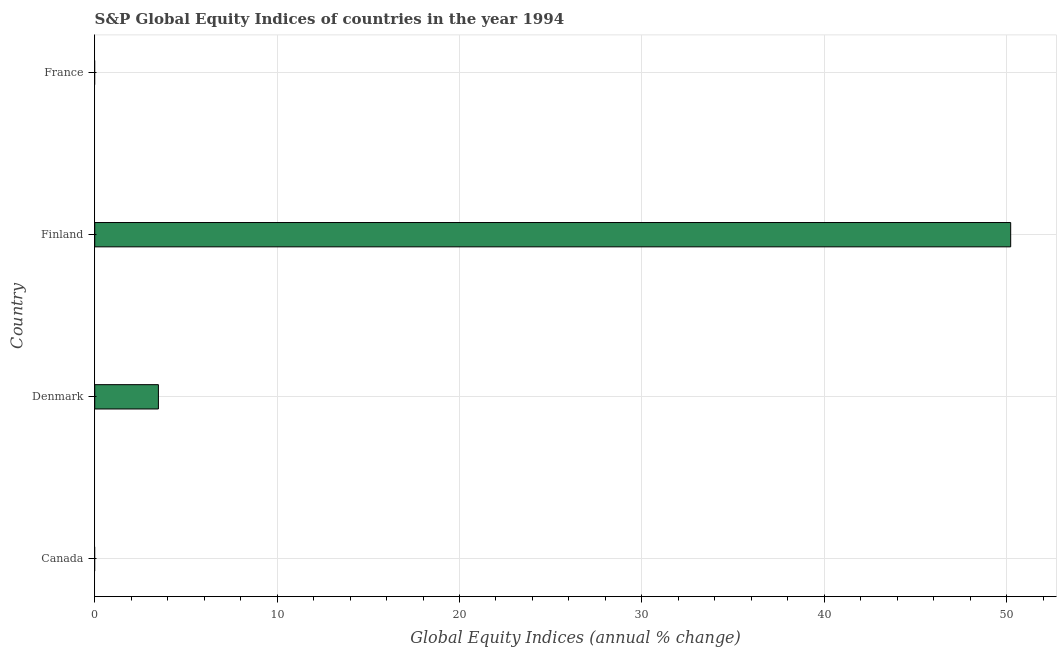Does the graph contain grids?
Offer a terse response. Yes. What is the title of the graph?
Provide a short and direct response. S&P Global Equity Indices of countries in the year 1994. What is the label or title of the X-axis?
Your response must be concise. Global Equity Indices (annual % change). What is the s&p global equity indices in Finland?
Make the answer very short. 50.23. Across all countries, what is the maximum s&p global equity indices?
Offer a very short reply. 50.23. Across all countries, what is the minimum s&p global equity indices?
Your response must be concise. 0. What is the sum of the s&p global equity indices?
Offer a very short reply. 53.72. What is the difference between the s&p global equity indices in Denmark and Finland?
Your answer should be very brief. -46.73. What is the average s&p global equity indices per country?
Your response must be concise. 13.43. What is the median s&p global equity indices?
Your response must be concise. 1.75. What is the ratio of the s&p global equity indices in Denmark to that in Finland?
Provide a short and direct response. 0.07. What is the difference between the highest and the lowest s&p global equity indices?
Make the answer very short. 50.23. In how many countries, is the s&p global equity indices greater than the average s&p global equity indices taken over all countries?
Offer a terse response. 1. Are all the bars in the graph horizontal?
Your answer should be very brief. Yes. How many countries are there in the graph?
Offer a terse response. 4. What is the difference between two consecutive major ticks on the X-axis?
Your answer should be very brief. 10. Are the values on the major ticks of X-axis written in scientific E-notation?
Ensure brevity in your answer.  No. What is the Global Equity Indices (annual % change) of Denmark?
Keep it short and to the point. 3.49. What is the Global Equity Indices (annual % change) in Finland?
Provide a short and direct response. 50.23. What is the difference between the Global Equity Indices (annual % change) in Denmark and Finland?
Your answer should be compact. -46.73. What is the ratio of the Global Equity Indices (annual % change) in Denmark to that in Finland?
Give a very brief answer. 0.07. 